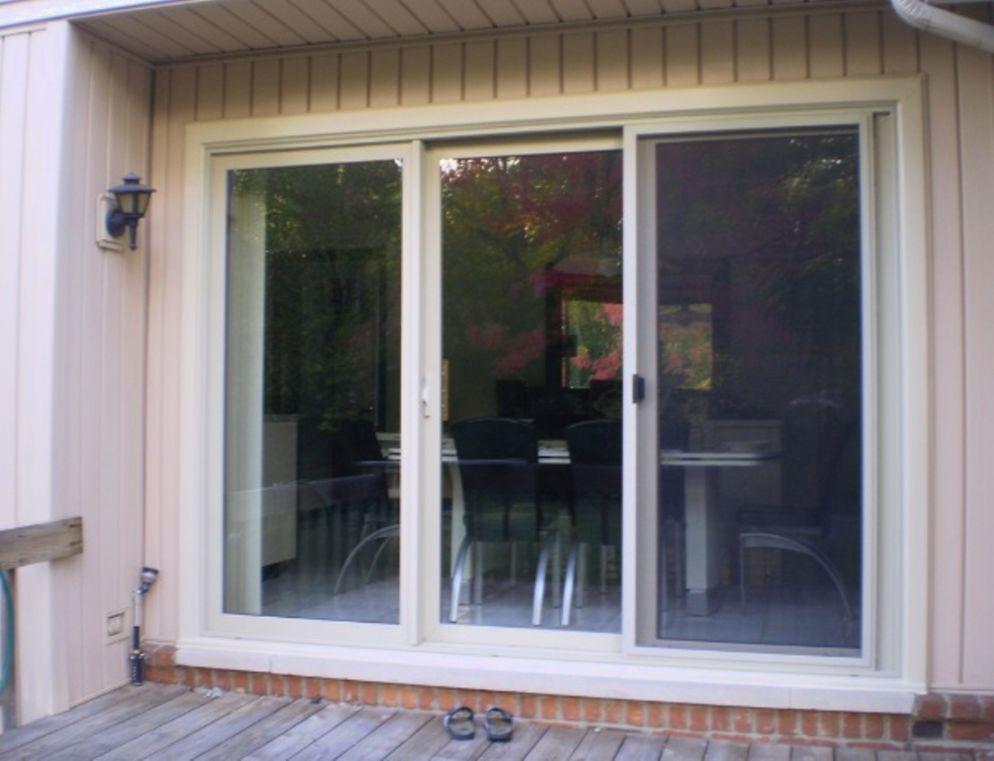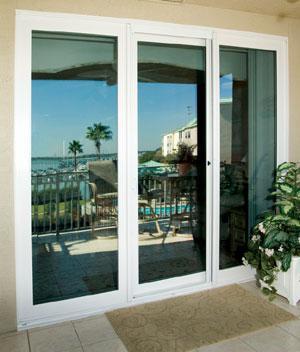The first image is the image on the left, the second image is the image on the right. Assess this claim about the two images: "Both sets of doors in the images are white.". Correct or not? Answer yes or no. Yes. The first image is the image on the left, the second image is the image on the right. Assess this claim about the two images: "An image shows a row of hinged glass panels forming an accordion-like pattern.". Correct or not? Answer yes or no. No. 